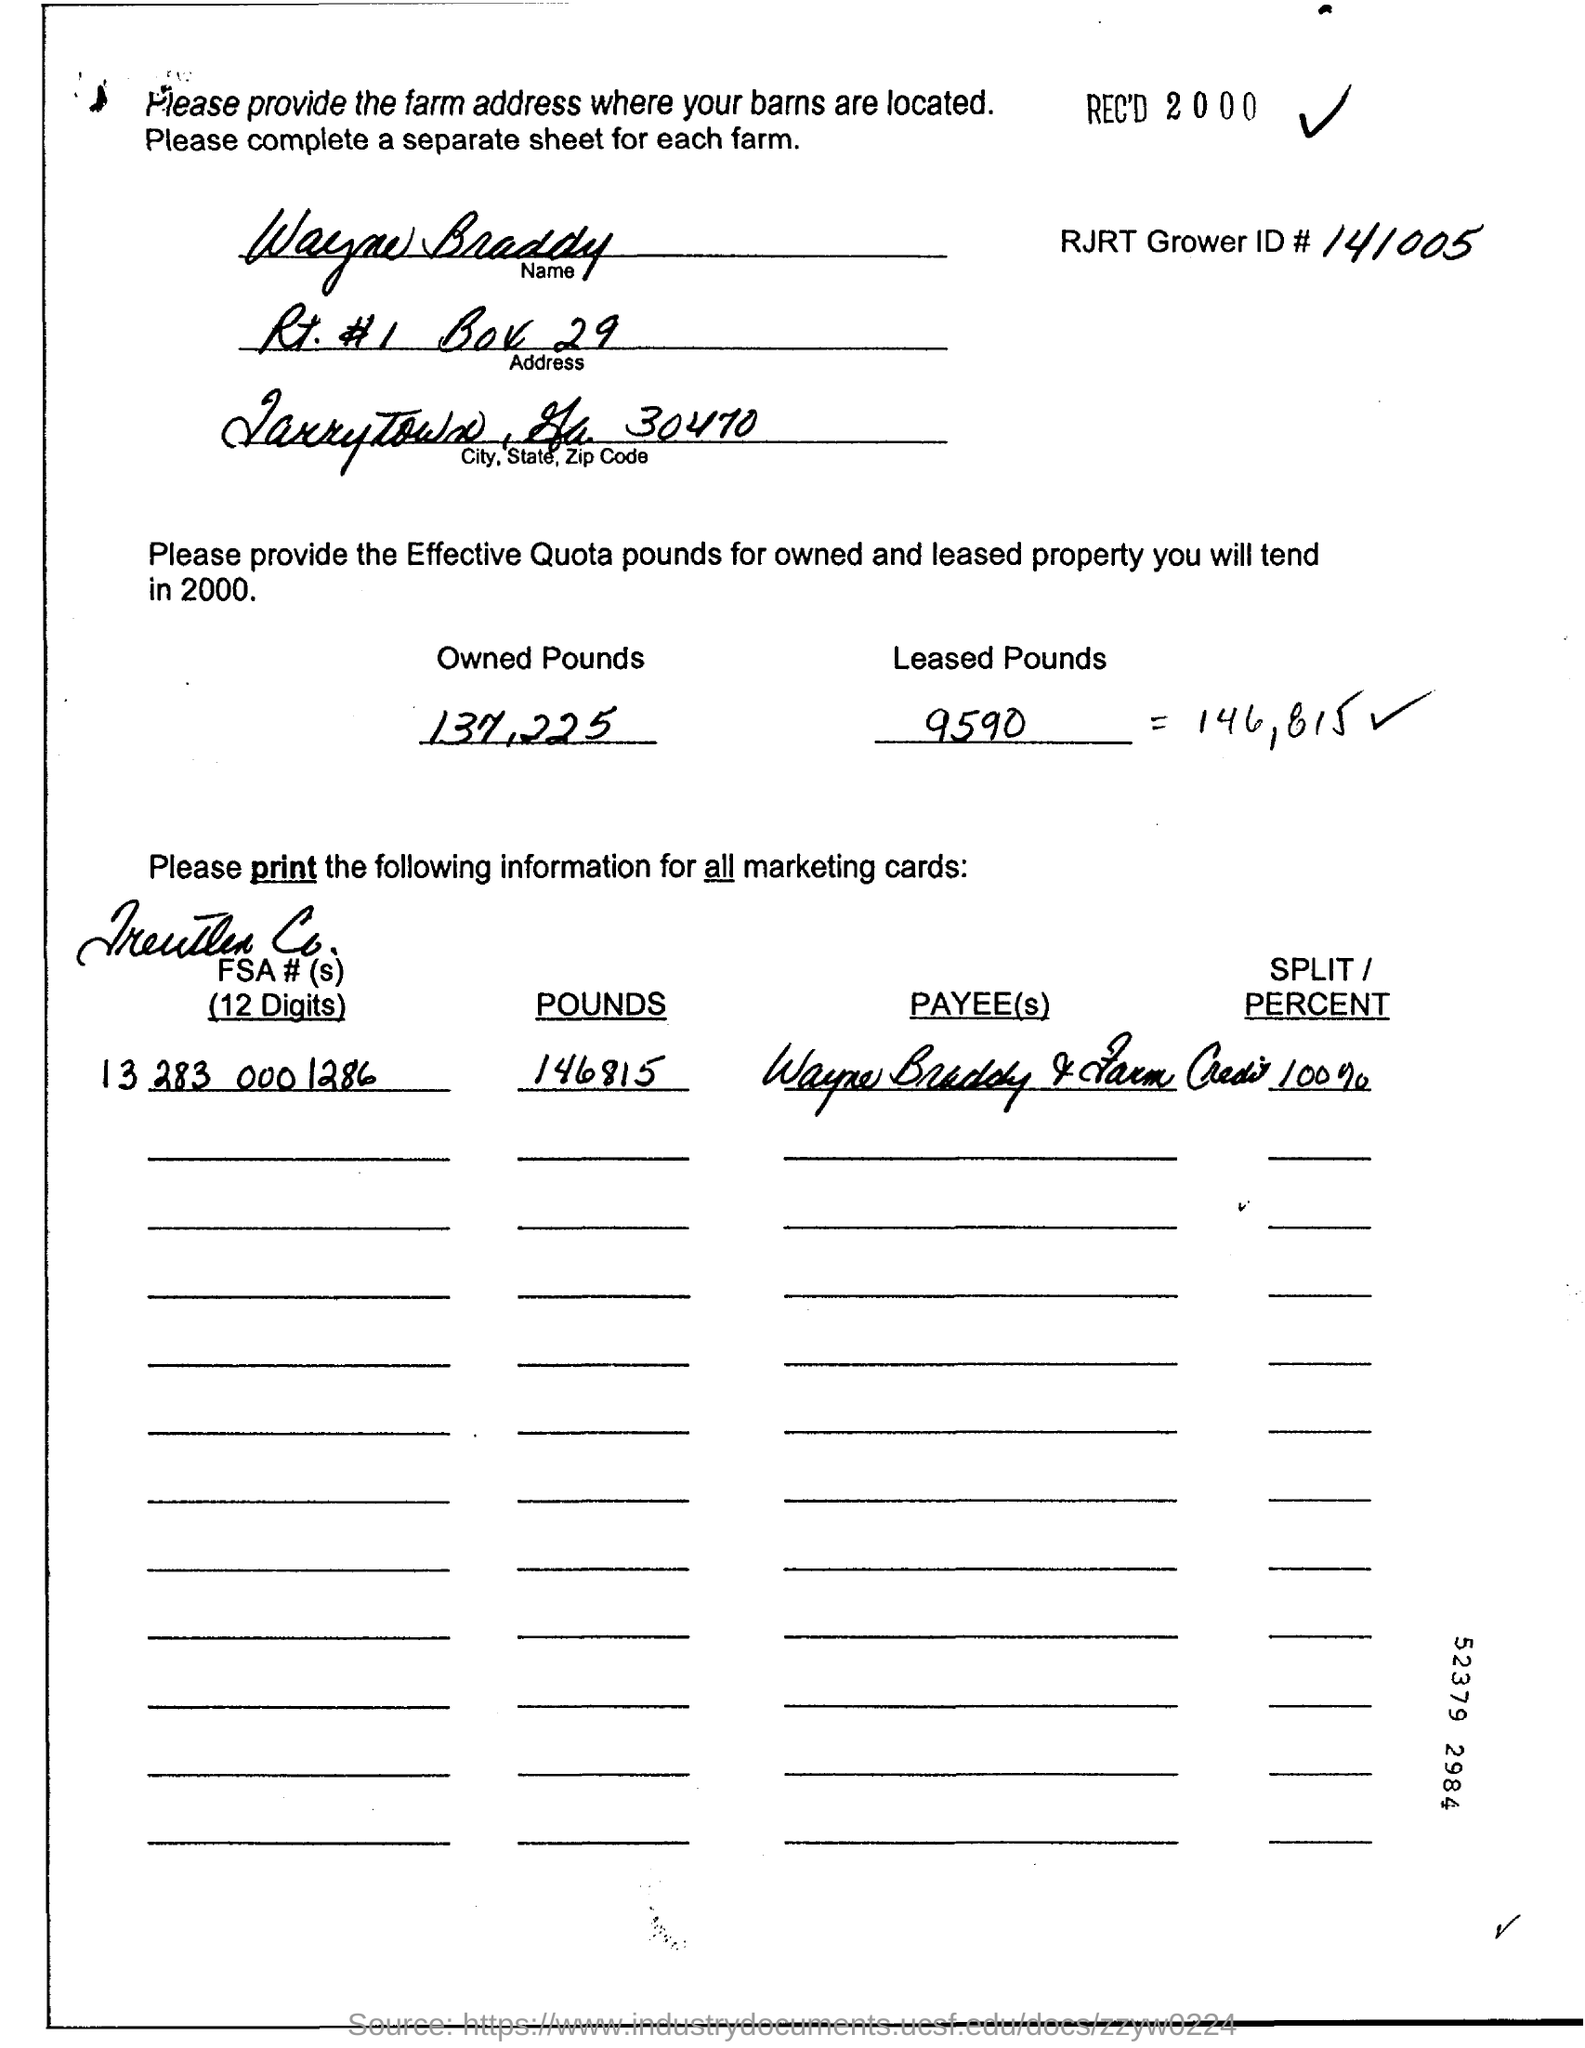How much are the Owned Pounds?
Your response must be concise. 137,225. How much are the Leased Pounds?
Your answer should be compact. 9590. 